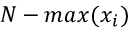<formula> <loc_0><loc_0><loc_500><loc_500>N - \max ( x _ { i } )</formula> 